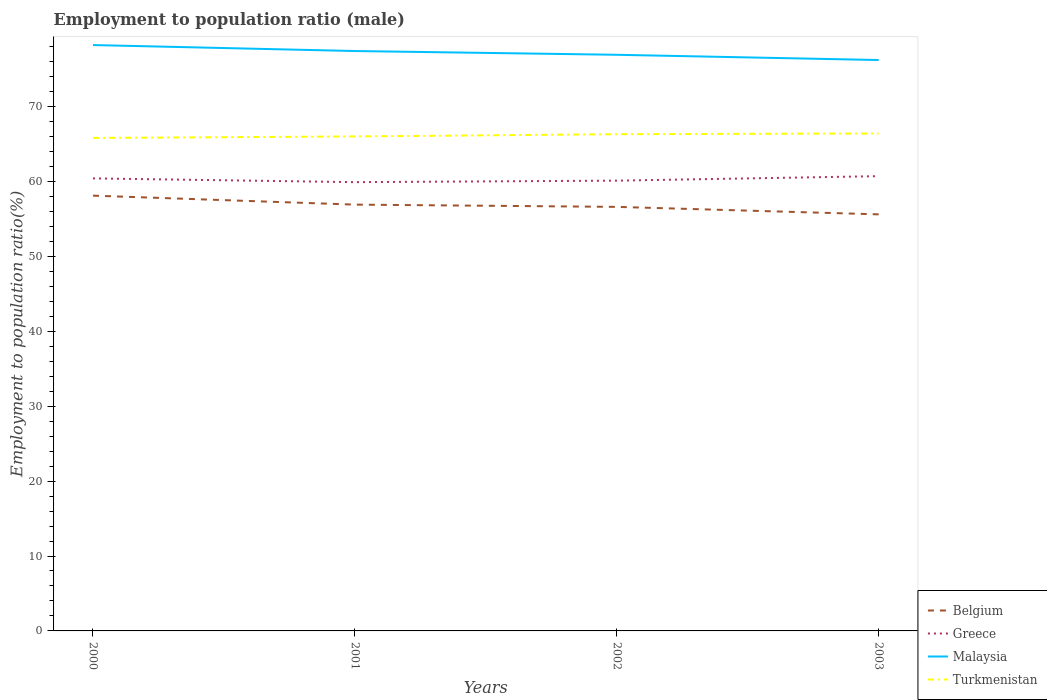How many different coloured lines are there?
Your answer should be compact. 4. Does the line corresponding to Malaysia intersect with the line corresponding to Greece?
Offer a very short reply. No. Is the number of lines equal to the number of legend labels?
Provide a succinct answer. Yes. Across all years, what is the maximum employment to population ratio in Greece?
Your answer should be very brief. 59.9. What is the total employment to population ratio in Belgium in the graph?
Provide a short and direct response. 0.3. What is the difference between the highest and the second highest employment to population ratio in Turkmenistan?
Keep it short and to the point. 0.6. Is the employment to population ratio in Greece strictly greater than the employment to population ratio in Turkmenistan over the years?
Make the answer very short. Yes. What is the difference between two consecutive major ticks on the Y-axis?
Your response must be concise. 10. Does the graph contain any zero values?
Offer a very short reply. No. Does the graph contain grids?
Provide a short and direct response. No. Where does the legend appear in the graph?
Provide a short and direct response. Bottom right. How many legend labels are there?
Keep it short and to the point. 4. How are the legend labels stacked?
Provide a succinct answer. Vertical. What is the title of the graph?
Offer a very short reply. Employment to population ratio (male). Does "Colombia" appear as one of the legend labels in the graph?
Provide a succinct answer. No. What is the Employment to population ratio(%) of Belgium in 2000?
Provide a short and direct response. 58.1. What is the Employment to population ratio(%) of Greece in 2000?
Offer a very short reply. 60.4. What is the Employment to population ratio(%) of Malaysia in 2000?
Ensure brevity in your answer.  78.2. What is the Employment to population ratio(%) in Turkmenistan in 2000?
Give a very brief answer. 65.8. What is the Employment to population ratio(%) in Belgium in 2001?
Provide a short and direct response. 56.9. What is the Employment to population ratio(%) in Greece in 2001?
Offer a terse response. 59.9. What is the Employment to population ratio(%) of Malaysia in 2001?
Provide a short and direct response. 77.4. What is the Employment to population ratio(%) of Turkmenistan in 2001?
Keep it short and to the point. 66. What is the Employment to population ratio(%) of Belgium in 2002?
Ensure brevity in your answer.  56.6. What is the Employment to population ratio(%) of Greece in 2002?
Offer a terse response. 60.1. What is the Employment to population ratio(%) in Malaysia in 2002?
Offer a terse response. 76.9. What is the Employment to population ratio(%) of Turkmenistan in 2002?
Make the answer very short. 66.3. What is the Employment to population ratio(%) in Belgium in 2003?
Keep it short and to the point. 55.6. What is the Employment to population ratio(%) of Greece in 2003?
Provide a short and direct response. 60.7. What is the Employment to population ratio(%) of Malaysia in 2003?
Give a very brief answer. 76.2. What is the Employment to population ratio(%) of Turkmenistan in 2003?
Provide a short and direct response. 66.4. Across all years, what is the maximum Employment to population ratio(%) of Belgium?
Keep it short and to the point. 58.1. Across all years, what is the maximum Employment to population ratio(%) of Greece?
Your answer should be very brief. 60.7. Across all years, what is the maximum Employment to population ratio(%) of Malaysia?
Provide a succinct answer. 78.2. Across all years, what is the maximum Employment to population ratio(%) of Turkmenistan?
Offer a terse response. 66.4. Across all years, what is the minimum Employment to population ratio(%) in Belgium?
Offer a terse response. 55.6. Across all years, what is the minimum Employment to population ratio(%) in Greece?
Keep it short and to the point. 59.9. Across all years, what is the minimum Employment to population ratio(%) of Malaysia?
Make the answer very short. 76.2. Across all years, what is the minimum Employment to population ratio(%) of Turkmenistan?
Your answer should be compact. 65.8. What is the total Employment to population ratio(%) in Belgium in the graph?
Offer a very short reply. 227.2. What is the total Employment to population ratio(%) of Greece in the graph?
Give a very brief answer. 241.1. What is the total Employment to population ratio(%) in Malaysia in the graph?
Provide a succinct answer. 308.7. What is the total Employment to population ratio(%) in Turkmenistan in the graph?
Your response must be concise. 264.5. What is the difference between the Employment to population ratio(%) in Greece in 2000 and that in 2001?
Give a very brief answer. 0.5. What is the difference between the Employment to population ratio(%) of Turkmenistan in 2000 and that in 2001?
Ensure brevity in your answer.  -0.2. What is the difference between the Employment to population ratio(%) of Malaysia in 2000 and that in 2002?
Offer a very short reply. 1.3. What is the difference between the Employment to population ratio(%) in Turkmenistan in 2000 and that in 2002?
Ensure brevity in your answer.  -0.5. What is the difference between the Employment to population ratio(%) of Belgium in 2000 and that in 2003?
Provide a short and direct response. 2.5. What is the difference between the Employment to population ratio(%) in Turkmenistan in 2000 and that in 2003?
Provide a short and direct response. -0.6. What is the difference between the Employment to population ratio(%) in Greece in 2001 and that in 2002?
Offer a very short reply. -0.2. What is the difference between the Employment to population ratio(%) of Greece in 2001 and that in 2003?
Your answer should be very brief. -0.8. What is the difference between the Employment to population ratio(%) in Malaysia in 2001 and that in 2003?
Keep it short and to the point. 1.2. What is the difference between the Employment to population ratio(%) in Turkmenistan in 2001 and that in 2003?
Provide a short and direct response. -0.4. What is the difference between the Employment to population ratio(%) in Greece in 2002 and that in 2003?
Offer a very short reply. -0.6. What is the difference between the Employment to population ratio(%) in Malaysia in 2002 and that in 2003?
Your answer should be compact. 0.7. What is the difference between the Employment to population ratio(%) in Turkmenistan in 2002 and that in 2003?
Offer a terse response. -0.1. What is the difference between the Employment to population ratio(%) of Belgium in 2000 and the Employment to population ratio(%) of Malaysia in 2001?
Make the answer very short. -19.3. What is the difference between the Employment to population ratio(%) in Belgium in 2000 and the Employment to population ratio(%) in Turkmenistan in 2001?
Your response must be concise. -7.9. What is the difference between the Employment to population ratio(%) in Greece in 2000 and the Employment to population ratio(%) in Malaysia in 2001?
Keep it short and to the point. -17. What is the difference between the Employment to population ratio(%) of Greece in 2000 and the Employment to population ratio(%) of Turkmenistan in 2001?
Provide a succinct answer. -5.6. What is the difference between the Employment to population ratio(%) in Belgium in 2000 and the Employment to population ratio(%) in Malaysia in 2002?
Your response must be concise. -18.8. What is the difference between the Employment to population ratio(%) in Greece in 2000 and the Employment to population ratio(%) in Malaysia in 2002?
Make the answer very short. -16.5. What is the difference between the Employment to population ratio(%) in Belgium in 2000 and the Employment to population ratio(%) in Malaysia in 2003?
Your answer should be compact. -18.1. What is the difference between the Employment to population ratio(%) in Greece in 2000 and the Employment to population ratio(%) in Malaysia in 2003?
Keep it short and to the point. -15.8. What is the difference between the Employment to population ratio(%) in Greece in 2000 and the Employment to population ratio(%) in Turkmenistan in 2003?
Ensure brevity in your answer.  -6. What is the difference between the Employment to population ratio(%) of Malaysia in 2000 and the Employment to population ratio(%) of Turkmenistan in 2003?
Give a very brief answer. 11.8. What is the difference between the Employment to population ratio(%) of Belgium in 2001 and the Employment to population ratio(%) of Greece in 2002?
Offer a terse response. -3.2. What is the difference between the Employment to population ratio(%) of Greece in 2001 and the Employment to population ratio(%) of Malaysia in 2002?
Your answer should be very brief. -17. What is the difference between the Employment to population ratio(%) in Belgium in 2001 and the Employment to population ratio(%) in Greece in 2003?
Your answer should be compact. -3.8. What is the difference between the Employment to population ratio(%) in Belgium in 2001 and the Employment to population ratio(%) in Malaysia in 2003?
Your answer should be very brief. -19.3. What is the difference between the Employment to population ratio(%) of Belgium in 2001 and the Employment to population ratio(%) of Turkmenistan in 2003?
Provide a succinct answer. -9.5. What is the difference between the Employment to population ratio(%) of Greece in 2001 and the Employment to population ratio(%) of Malaysia in 2003?
Ensure brevity in your answer.  -16.3. What is the difference between the Employment to population ratio(%) of Greece in 2001 and the Employment to population ratio(%) of Turkmenistan in 2003?
Provide a succinct answer. -6.5. What is the difference between the Employment to population ratio(%) of Malaysia in 2001 and the Employment to population ratio(%) of Turkmenistan in 2003?
Your answer should be compact. 11. What is the difference between the Employment to population ratio(%) in Belgium in 2002 and the Employment to population ratio(%) in Greece in 2003?
Offer a very short reply. -4.1. What is the difference between the Employment to population ratio(%) in Belgium in 2002 and the Employment to population ratio(%) in Malaysia in 2003?
Your response must be concise. -19.6. What is the difference between the Employment to population ratio(%) of Greece in 2002 and the Employment to population ratio(%) of Malaysia in 2003?
Your response must be concise. -16.1. What is the average Employment to population ratio(%) in Belgium per year?
Ensure brevity in your answer.  56.8. What is the average Employment to population ratio(%) of Greece per year?
Offer a very short reply. 60.27. What is the average Employment to population ratio(%) of Malaysia per year?
Your response must be concise. 77.17. What is the average Employment to population ratio(%) in Turkmenistan per year?
Ensure brevity in your answer.  66.12. In the year 2000, what is the difference between the Employment to population ratio(%) in Belgium and Employment to population ratio(%) in Malaysia?
Offer a terse response. -20.1. In the year 2000, what is the difference between the Employment to population ratio(%) in Greece and Employment to population ratio(%) in Malaysia?
Offer a very short reply. -17.8. In the year 2000, what is the difference between the Employment to population ratio(%) in Malaysia and Employment to population ratio(%) in Turkmenistan?
Your answer should be compact. 12.4. In the year 2001, what is the difference between the Employment to population ratio(%) in Belgium and Employment to population ratio(%) in Greece?
Your response must be concise. -3. In the year 2001, what is the difference between the Employment to population ratio(%) of Belgium and Employment to population ratio(%) of Malaysia?
Make the answer very short. -20.5. In the year 2001, what is the difference between the Employment to population ratio(%) in Greece and Employment to population ratio(%) in Malaysia?
Ensure brevity in your answer.  -17.5. In the year 2001, what is the difference between the Employment to population ratio(%) in Greece and Employment to population ratio(%) in Turkmenistan?
Provide a succinct answer. -6.1. In the year 2001, what is the difference between the Employment to population ratio(%) in Malaysia and Employment to population ratio(%) in Turkmenistan?
Your response must be concise. 11.4. In the year 2002, what is the difference between the Employment to population ratio(%) in Belgium and Employment to population ratio(%) in Greece?
Provide a short and direct response. -3.5. In the year 2002, what is the difference between the Employment to population ratio(%) in Belgium and Employment to population ratio(%) in Malaysia?
Your response must be concise. -20.3. In the year 2002, what is the difference between the Employment to population ratio(%) of Belgium and Employment to population ratio(%) of Turkmenistan?
Keep it short and to the point. -9.7. In the year 2002, what is the difference between the Employment to population ratio(%) in Greece and Employment to population ratio(%) in Malaysia?
Your response must be concise. -16.8. In the year 2003, what is the difference between the Employment to population ratio(%) in Belgium and Employment to population ratio(%) in Malaysia?
Make the answer very short. -20.6. In the year 2003, what is the difference between the Employment to population ratio(%) in Belgium and Employment to population ratio(%) in Turkmenistan?
Offer a terse response. -10.8. In the year 2003, what is the difference between the Employment to population ratio(%) of Greece and Employment to population ratio(%) of Malaysia?
Offer a very short reply. -15.5. In the year 2003, what is the difference between the Employment to population ratio(%) in Greece and Employment to population ratio(%) in Turkmenistan?
Your answer should be compact. -5.7. What is the ratio of the Employment to population ratio(%) in Belgium in 2000 to that in 2001?
Ensure brevity in your answer.  1.02. What is the ratio of the Employment to population ratio(%) in Greece in 2000 to that in 2001?
Offer a terse response. 1.01. What is the ratio of the Employment to population ratio(%) in Malaysia in 2000 to that in 2001?
Your response must be concise. 1.01. What is the ratio of the Employment to population ratio(%) in Belgium in 2000 to that in 2002?
Give a very brief answer. 1.03. What is the ratio of the Employment to population ratio(%) in Greece in 2000 to that in 2002?
Ensure brevity in your answer.  1. What is the ratio of the Employment to population ratio(%) of Malaysia in 2000 to that in 2002?
Offer a terse response. 1.02. What is the ratio of the Employment to population ratio(%) of Turkmenistan in 2000 to that in 2002?
Your response must be concise. 0.99. What is the ratio of the Employment to population ratio(%) in Belgium in 2000 to that in 2003?
Give a very brief answer. 1.04. What is the ratio of the Employment to population ratio(%) of Greece in 2000 to that in 2003?
Your answer should be very brief. 1. What is the ratio of the Employment to population ratio(%) of Malaysia in 2000 to that in 2003?
Make the answer very short. 1.03. What is the ratio of the Employment to population ratio(%) in Belgium in 2001 to that in 2002?
Provide a succinct answer. 1.01. What is the ratio of the Employment to population ratio(%) in Belgium in 2001 to that in 2003?
Your answer should be compact. 1.02. What is the ratio of the Employment to population ratio(%) of Malaysia in 2001 to that in 2003?
Give a very brief answer. 1.02. What is the ratio of the Employment to population ratio(%) in Malaysia in 2002 to that in 2003?
Offer a terse response. 1.01. What is the difference between the highest and the second highest Employment to population ratio(%) in Greece?
Provide a short and direct response. 0.3. What is the difference between the highest and the lowest Employment to population ratio(%) of Greece?
Your answer should be very brief. 0.8. What is the difference between the highest and the lowest Employment to population ratio(%) in Turkmenistan?
Your answer should be very brief. 0.6. 